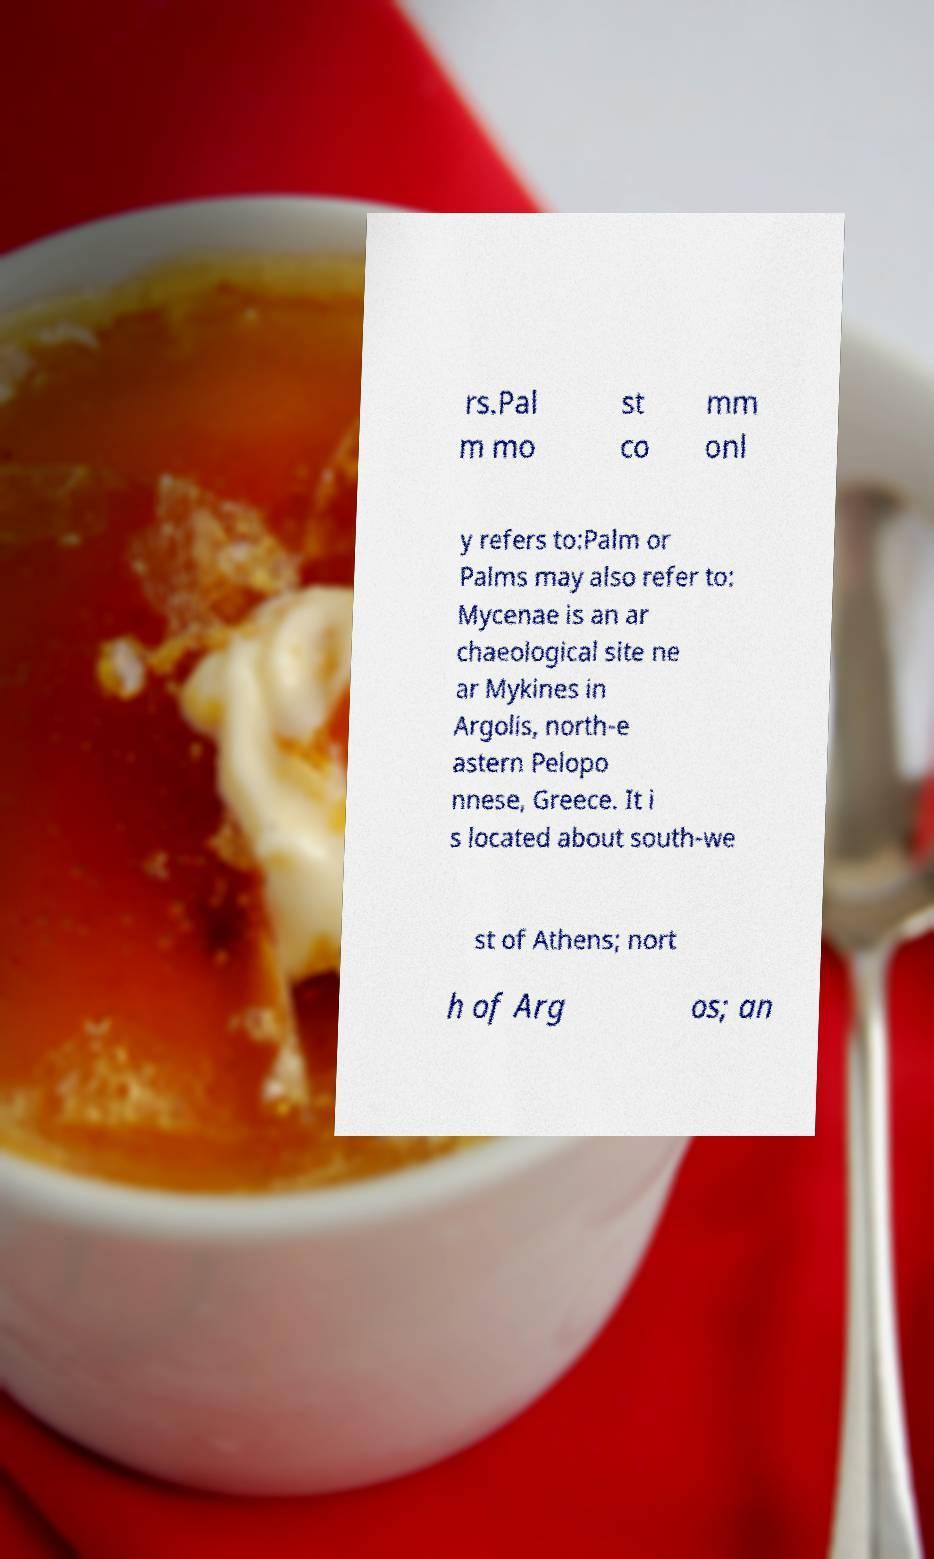Could you extract and type out the text from this image? rs.Pal m mo st co mm onl y refers to:Palm or Palms may also refer to: Mycenae is an ar chaeological site ne ar Mykines in Argolis, north-e astern Pelopo nnese, Greece. It i s located about south-we st of Athens; nort h of Arg os; an 